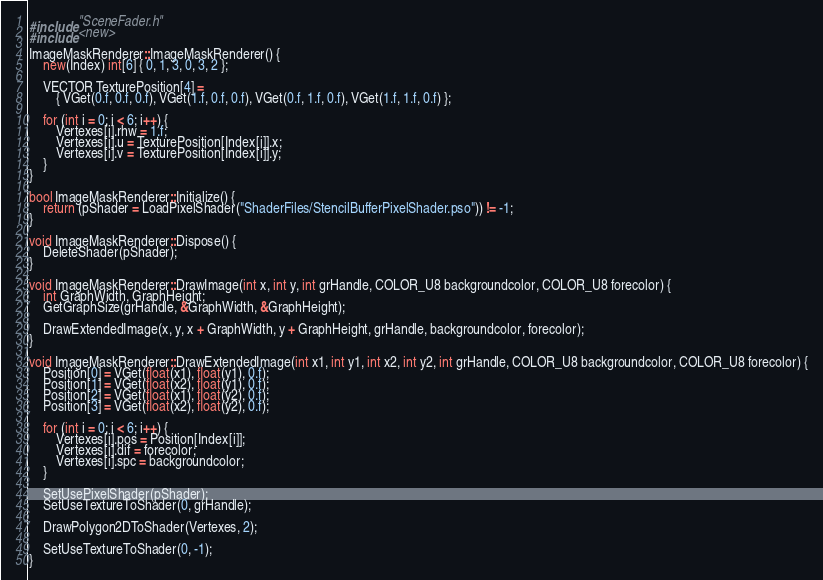Convert code to text. <code><loc_0><loc_0><loc_500><loc_500><_C++_>#include "SceneFader.h"
#include <new>

ImageMaskRenderer::ImageMaskRenderer() {
	new(Index) int[6] { 0, 1, 3, 0, 3, 2 };
	
	VECTOR TexturePosition[4] =
		{ VGet(0.f, 0.f, 0.f), VGet(1.f, 0.f, 0.f), VGet(0.f, 1.f, 0.f), VGet(1.f, 1.f, 0.f) };

	for (int i = 0; i < 6; i++) {
		Vertexes[i].rhw = 1.f;
		Vertexes[i].u = TexturePosition[Index[i]].x;
		Vertexes[i].v = TexturePosition[Index[i]].y;
	}
}

bool ImageMaskRenderer::Initialize() {
	return (pShader = LoadPixelShader("ShaderFiles/StencilBufferPixelShader.pso")) != -1;
}

void ImageMaskRenderer::Dispose() {
	DeleteShader(pShader);
}

void ImageMaskRenderer::DrawImage(int x, int y, int grHandle, COLOR_U8 backgroundcolor, COLOR_U8 forecolor) {
	int GraphWidth, GraphHeight;
	GetGraphSize(grHandle, &GraphWidth, &GraphHeight);

	DrawExtendedImage(x, y, x + GraphWidth, y + GraphHeight, grHandle, backgroundcolor, forecolor);
}

void ImageMaskRenderer::DrawExtendedImage(int x1, int y1, int x2, int y2, int grHandle, COLOR_U8 backgroundcolor, COLOR_U8 forecolor) {
	Position[0] = VGet(float(x1), float(y1), 0.f);
	Position[1] = VGet(float(x2), float(y1), 0.f);
	Position[2] = VGet(float(x1), float(y2), 0.f);
	Position[3] = VGet(float(x2), float(y2), 0.f);
	
	for (int i = 0; i < 6; i++) {
		Vertexes[i].pos = Position[Index[i]];
		Vertexes[i].dif = forecolor;
		Vertexes[i].spc = backgroundcolor;
	}

	SetUsePixelShader(pShader);
	SetUseTextureToShader(0, grHandle);
	
	DrawPolygon2DToShader(Vertexes, 2);

	SetUseTextureToShader(0, -1);
}</code> 